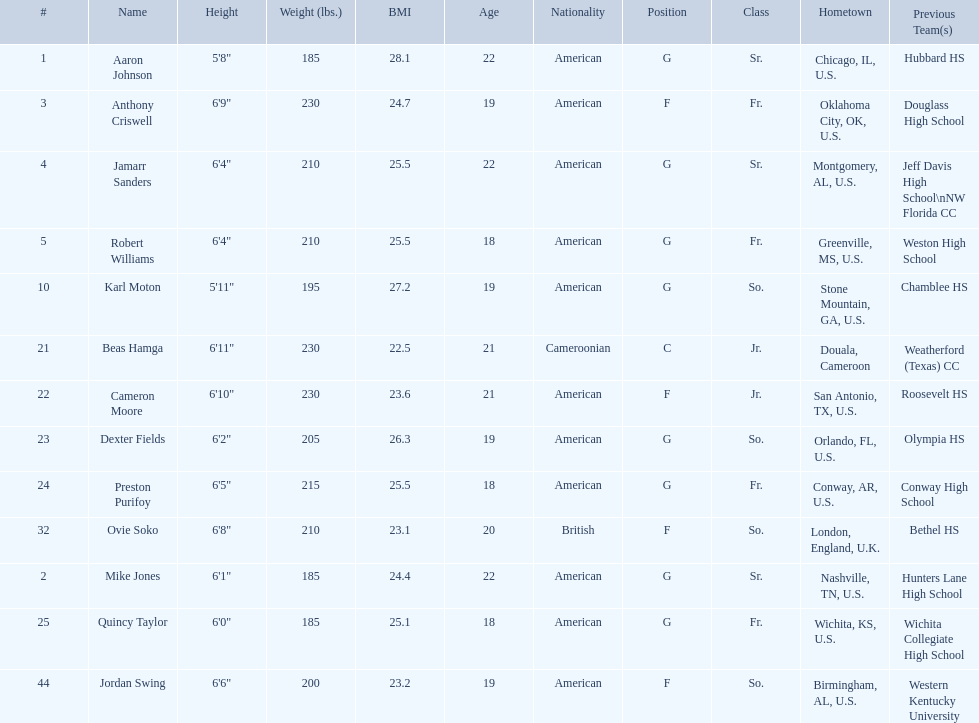Other than soko, who are the players? Aaron Johnson, Anthony Criswell, Jamarr Sanders, Robert Williams, Karl Moton, Beas Hamga, Cameron Moore, Dexter Fields, Preston Purifoy, Mike Jones, Quincy Taylor, Jordan Swing. Of those players, who is a player that is not from the us? Beas Hamga. 